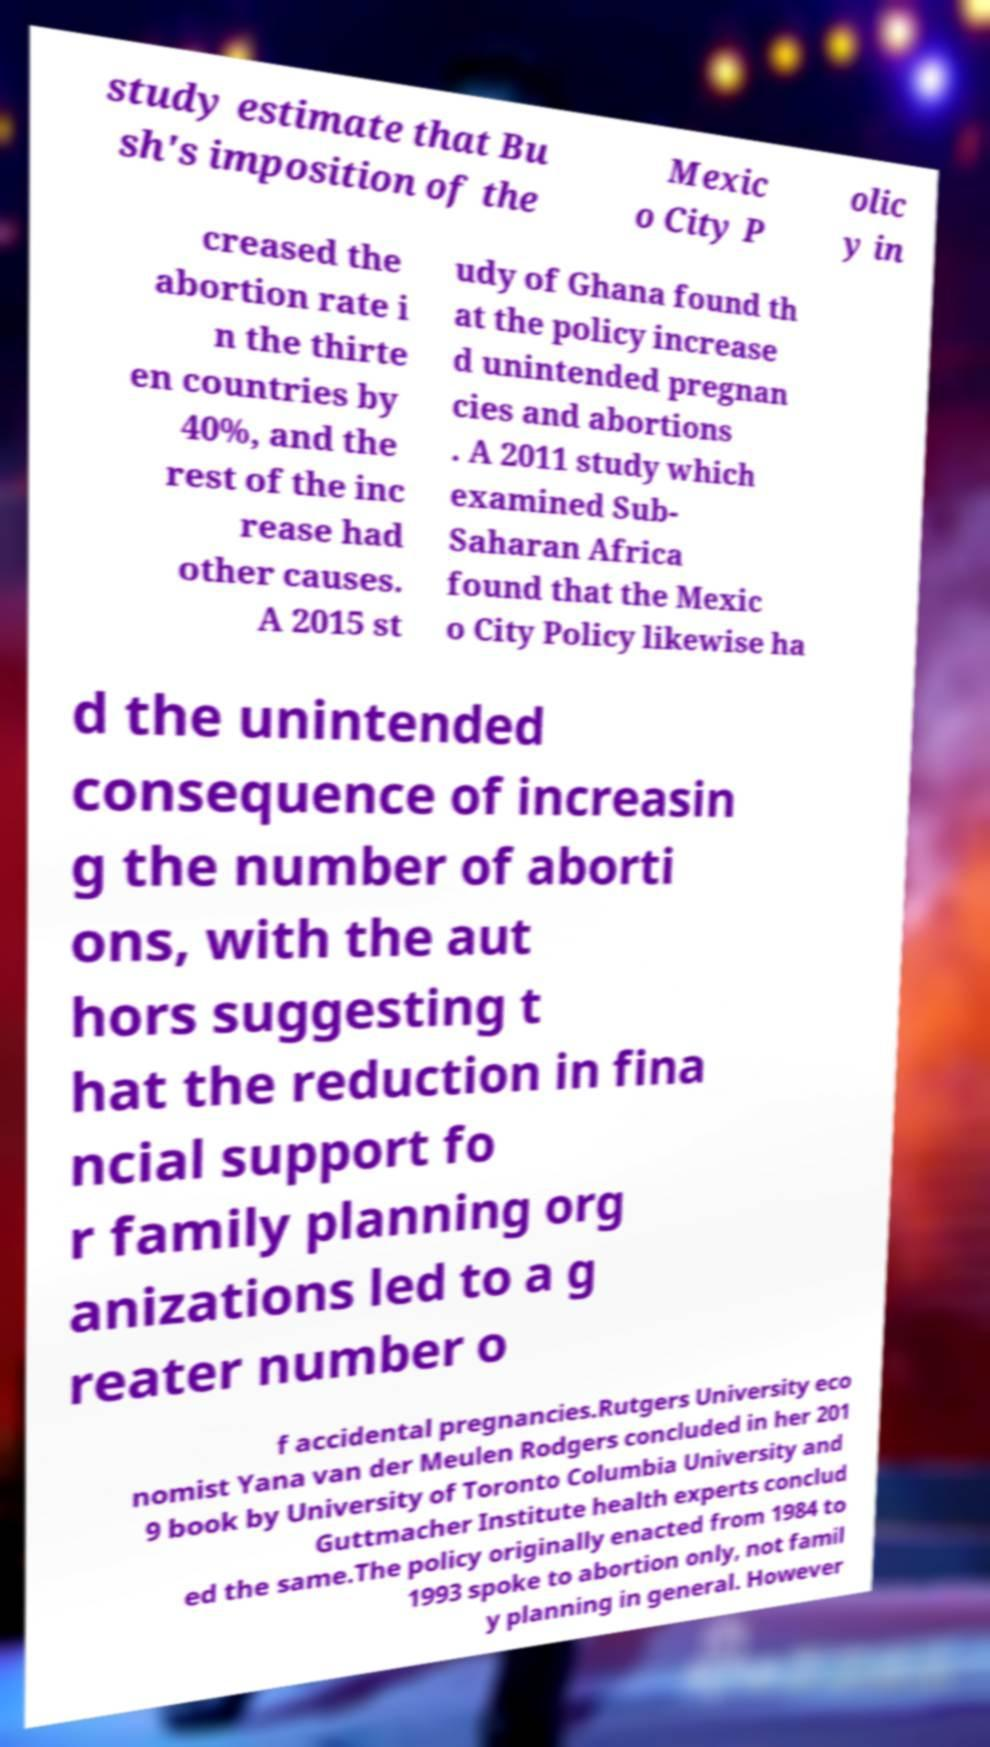There's text embedded in this image that I need extracted. Can you transcribe it verbatim? study estimate that Bu sh's imposition of the Mexic o City P olic y in creased the abortion rate i n the thirte en countries by 40%, and the rest of the inc rease had other causes. A 2015 st udy of Ghana found th at the policy increase d unintended pregnan cies and abortions . A 2011 study which examined Sub- Saharan Africa found that the Mexic o City Policy likewise ha d the unintended consequence of increasin g the number of aborti ons, with the aut hors suggesting t hat the reduction in fina ncial support fo r family planning org anizations led to a g reater number o f accidental pregnancies.Rutgers University eco nomist Yana van der Meulen Rodgers concluded in her 201 9 book by University of Toronto Columbia University and Guttmacher Institute health experts conclud ed the same.The policy originally enacted from 1984 to 1993 spoke to abortion only, not famil y planning in general. However 